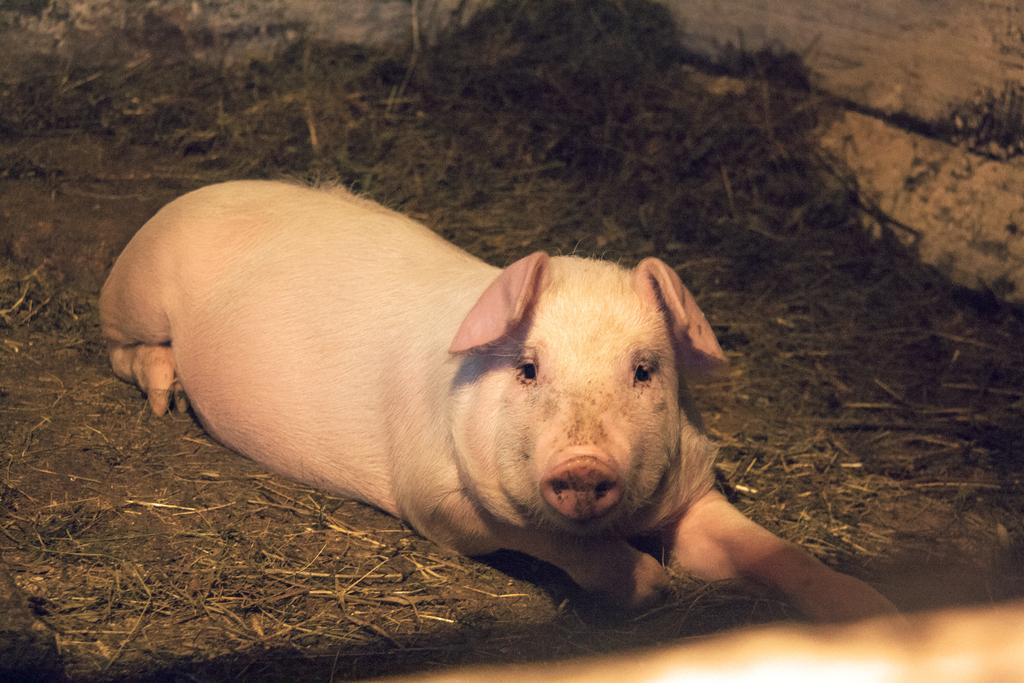What animal is present in the image? There is a pig in the image. What position is the pig in? The pig is laying on the ground. What can be seen in the background of the image? There is grass and a wall in the background of the image. What type of coat is the pig wearing in the image? The pig is not wearing a coat in the image. Pigs do not wear coats. 